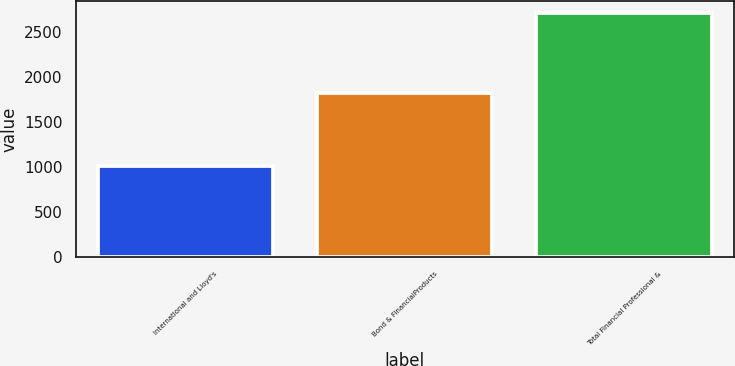Convert chart. <chart><loc_0><loc_0><loc_500><loc_500><bar_chart><fcel>International and Lloyd's<fcel>Bond & FinancialProducts<fcel>Total Financial Professional &<nl><fcel>1011<fcel>1819<fcel>2708<nl></chart> 